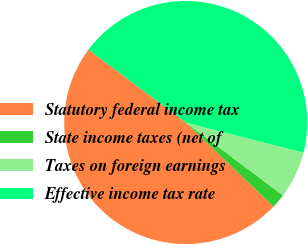Convert chart to OTSL. <chart><loc_0><loc_0><loc_500><loc_500><pie_chart><fcel>Statutory federal income tax<fcel>State income taxes (net of<fcel>Taxes on foreign earnings<fcel>Effective income tax rate<nl><fcel>48.07%<fcel>1.93%<fcel>6.24%<fcel>43.76%<nl></chart> 